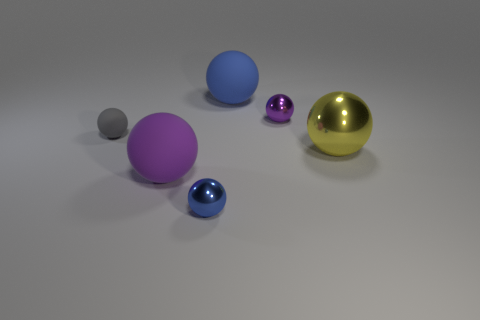Which of the balls in the image appears to be the most reflective? The golden ball in the image appears to be the most reflective. Its surface clearly mirrors the environment, showing a high degree of reflectivity. 